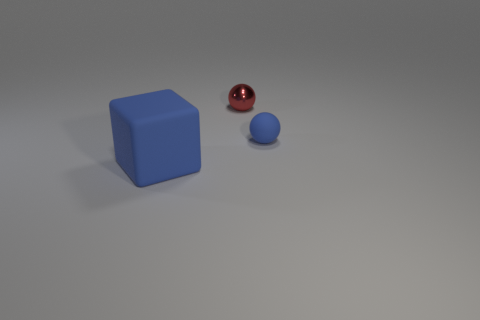Add 2 red objects. How many objects exist? 5 Subtract all balls. How many objects are left? 1 Add 1 matte cubes. How many matte cubes are left? 2 Add 3 tiny red metal things. How many tiny red metal things exist? 4 Subtract 0 yellow cylinders. How many objects are left? 3 Subtract all small blue spheres. Subtract all small green metallic spheres. How many objects are left? 2 